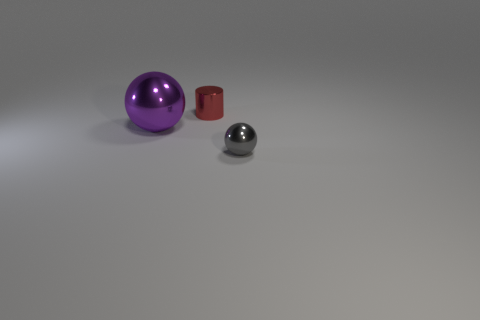How many purple shiny spheres are there?
Offer a very short reply. 1. There is a tiny metallic ball; are there any tiny metallic objects behind it?
Offer a very short reply. Yes. Do the red metal thing and the gray metal thing have the same size?
Ensure brevity in your answer.  Yes. What number of purple spheres are made of the same material as the tiny red thing?
Provide a succinct answer. 1. What size is the metal thing that is in front of the metal sphere that is left of the tiny gray shiny thing?
Your response must be concise. Small. What is the color of the metal thing that is behind the small gray thing and on the right side of the large purple ball?
Keep it short and to the point. Red. Do the big thing and the small gray object have the same shape?
Provide a short and direct response. Yes. There is a tiny object on the left side of the gray sphere right of the big shiny sphere; what is its shape?
Your response must be concise. Cylinder. Does the gray object have the same shape as the thing that is to the left of the red cylinder?
Your answer should be very brief. Yes. The other metal object that is the same size as the red shiny object is what color?
Give a very brief answer. Gray. 